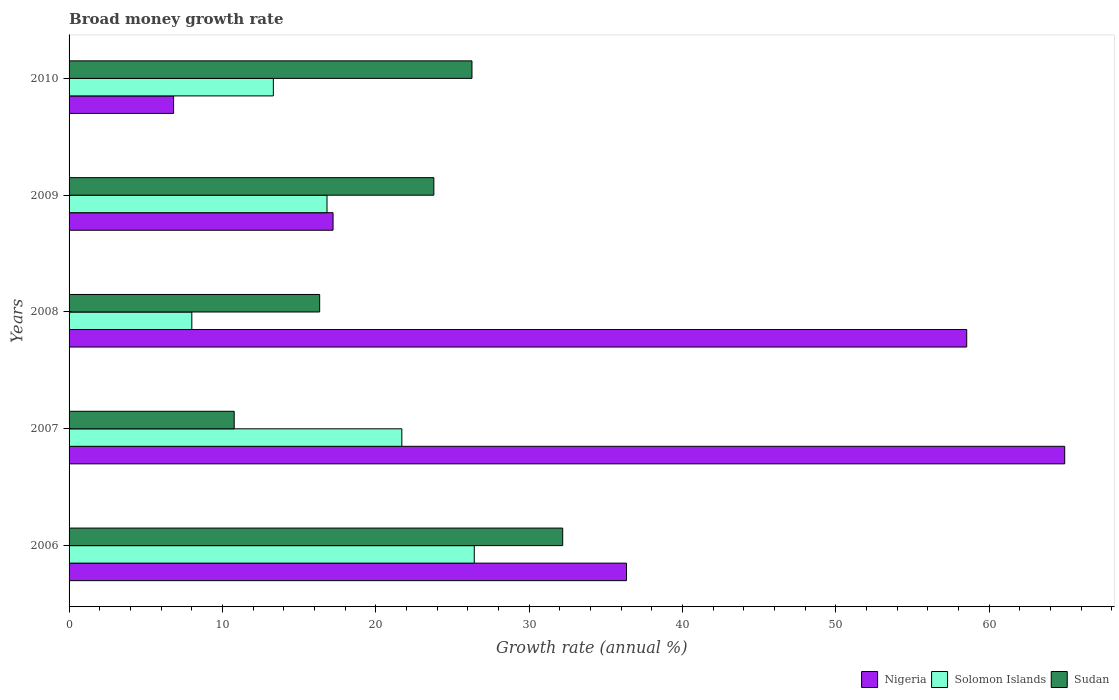How many groups of bars are there?
Give a very brief answer. 5. Are the number of bars on each tick of the Y-axis equal?
Your answer should be compact. Yes. How many bars are there on the 4th tick from the top?
Make the answer very short. 3. How many bars are there on the 1st tick from the bottom?
Offer a terse response. 3. What is the label of the 4th group of bars from the top?
Make the answer very short. 2007. In how many cases, is the number of bars for a given year not equal to the number of legend labels?
Keep it short and to the point. 0. What is the growth rate in Sudan in 2009?
Your answer should be very brief. 23.79. Across all years, what is the maximum growth rate in Nigeria?
Offer a terse response. 64.92. Across all years, what is the minimum growth rate in Nigeria?
Provide a short and direct response. 6.82. What is the total growth rate in Nigeria in the graph?
Keep it short and to the point. 183.84. What is the difference between the growth rate in Sudan in 2007 and that in 2010?
Your response must be concise. -15.5. What is the difference between the growth rate in Solomon Islands in 2010 and the growth rate in Sudan in 2007?
Ensure brevity in your answer.  2.55. What is the average growth rate in Nigeria per year?
Your response must be concise. 36.77. In the year 2008, what is the difference between the growth rate in Solomon Islands and growth rate in Nigeria?
Your response must be concise. -50.53. What is the ratio of the growth rate in Sudan in 2006 to that in 2010?
Offer a terse response. 1.23. What is the difference between the highest and the second highest growth rate in Nigeria?
Give a very brief answer. 6.39. What is the difference between the highest and the lowest growth rate in Nigeria?
Provide a short and direct response. 58.11. What does the 1st bar from the top in 2009 represents?
Provide a succinct answer. Sudan. What does the 1st bar from the bottom in 2009 represents?
Offer a terse response. Nigeria. Is it the case that in every year, the sum of the growth rate in Solomon Islands and growth rate in Nigeria is greater than the growth rate in Sudan?
Keep it short and to the point. No. How many bars are there?
Provide a succinct answer. 15. Are all the bars in the graph horizontal?
Offer a very short reply. Yes. How many years are there in the graph?
Keep it short and to the point. 5. Where does the legend appear in the graph?
Your answer should be very brief. Bottom right. How are the legend labels stacked?
Ensure brevity in your answer.  Horizontal. What is the title of the graph?
Offer a very short reply. Broad money growth rate. What is the label or title of the X-axis?
Give a very brief answer. Growth rate (annual %). What is the label or title of the Y-axis?
Provide a succinct answer. Years. What is the Growth rate (annual %) in Nigeria in 2006?
Provide a short and direct response. 36.35. What is the Growth rate (annual %) in Solomon Islands in 2006?
Give a very brief answer. 26.42. What is the Growth rate (annual %) in Sudan in 2006?
Offer a very short reply. 32.19. What is the Growth rate (annual %) of Nigeria in 2007?
Offer a terse response. 64.92. What is the Growth rate (annual %) in Solomon Islands in 2007?
Make the answer very short. 21.7. What is the Growth rate (annual %) of Sudan in 2007?
Your response must be concise. 10.77. What is the Growth rate (annual %) of Nigeria in 2008?
Make the answer very short. 58.53. What is the Growth rate (annual %) in Solomon Islands in 2008?
Your answer should be compact. 8.01. What is the Growth rate (annual %) in Sudan in 2008?
Your answer should be very brief. 16.34. What is the Growth rate (annual %) of Nigeria in 2009?
Make the answer very short. 17.21. What is the Growth rate (annual %) in Solomon Islands in 2009?
Provide a short and direct response. 16.82. What is the Growth rate (annual %) in Sudan in 2009?
Give a very brief answer. 23.79. What is the Growth rate (annual %) of Nigeria in 2010?
Provide a succinct answer. 6.82. What is the Growth rate (annual %) in Solomon Islands in 2010?
Give a very brief answer. 13.32. What is the Growth rate (annual %) of Sudan in 2010?
Make the answer very short. 26.27. Across all years, what is the maximum Growth rate (annual %) of Nigeria?
Offer a very short reply. 64.92. Across all years, what is the maximum Growth rate (annual %) of Solomon Islands?
Your answer should be compact. 26.42. Across all years, what is the maximum Growth rate (annual %) in Sudan?
Give a very brief answer. 32.19. Across all years, what is the minimum Growth rate (annual %) of Nigeria?
Keep it short and to the point. 6.82. Across all years, what is the minimum Growth rate (annual %) of Solomon Islands?
Your answer should be compact. 8.01. Across all years, what is the minimum Growth rate (annual %) in Sudan?
Offer a very short reply. 10.77. What is the total Growth rate (annual %) in Nigeria in the graph?
Ensure brevity in your answer.  183.84. What is the total Growth rate (annual %) in Solomon Islands in the graph?
Provide a succinct answer. 86.27. What is the total Growth rate (annual %) of Sudan in the graph?
Provide a succinct answer. 109.36. What is the difference between the Growth rate (annual %) in Nigeria in 2006 and that in 2007?
Ensure brevity in your answer.  -28.57. What is the difference between the Growth rate (annual %) in Solomon Islands in 2006 and that in 2007?
Provide a succinct answer. 4.72. What is the difference between the Growth rate (annual %) of Sudan in 2006 and that in 2007?
Keep it short and to the point. 21.42. What is the difference between the Growth rate (annual %) in Nigeria in 2006 and that in 2008?
Your response must be concise. -22.18. What is the difference between the Growth rate (annual %) of Solomon Islands in 2006 and that in 2008?
Offer a very short reply. 18.42. What is the difference between the Growth rate (annual %) in Sudan in 2006 and that in 2008?
Ensure brevity in your answer.  15.85. What is the difference between the Growth rate (annual %) in Nigeria in 2006 and that in 2009?
Offer a very short reply. 19.14. What is the difference between the Growth rate (annual %) of Solomon Islands in 2006 and that in 2009?
Provide a short and direct response. 9.6. What is the difference between the Growth rate (annual %) in Sudan in 2006 and that in 2009?
Keep it short and to the point. 8.4. What is the difference between the Growth rate (annual %) in Nigeria in 2006 and that in 2010?
Ensure brevity in your answer.  29.53. What is the difference between the Growth rate (annual %) in Solomon Islands in 2006 and that in 2010?
Give a very brief answer. 13.1. What is the difference between the Growth rate (annual %) of Sudan in 2006 and that in 2010?
Ensure brevity in your answer.  5.92. What is the difference between the Growth rate (annual %) in Nigeria in 2007 and that in 2008?
Give a very brief answer. 6.39. What is the difference between the Growth rate (annual %) of Solomon Islands in 2007 and that in 2008?
Ensure brevity in your answer.  13.7. What is the difference between the Growth rate (annual %) in Sudan in 2007 and that in 2008?
Ensure brevity in your answer.  -5.57. What is the difference between the Growth rate (annual %) in Nigeria in 2007 and that in 2009?
Provide a succinct answer. 47.71. What is the difference between the Growth rate (annual %) in Solomon Islands in 2007 and that in 2009?
Keep it short and to the point. 4.88. What is the difference between the Growth rate (annual %) of Sudan in 2007 and that in 2009?
Ensure brevity in your answer.  -13.02. What is the difference between the Growth rate (annual %) of Nigeria in 2007 and that in 2010?
Provide a succinct answer. 58.11. What is the difference between the Growth rate (annual %) of Solomon Islands in 2007 and that in 2010?
Ensure brevity in your answer.  8.38. What is the difference between the Growth rate (annual %) in Sudan in 2007 and that in 2010?
Provide a succinct answer. -15.5. What is the difference between the Growth rate (annual %) of Nigeria in 2008 and that in 2009?
Your answer should be compact. 41.32. What is the difference between the Growth rate (annual %) of Solomon Islands in 2008 and that in 2009?
Offer a very short reply. -8.81. What is the difference between the Growth rate (annual %) of Sudan in 2008 and that in 2009?
Your answer should be very brief. -7.45. What is the difference between the Growth rate (annual %) in Nigeria in 2008 and that in 2010?
Provide a succinct answer. 51.72. What is the difference between the Growth rate (annual %) of Solomon Islands in 2008 and that in 2010?
Make the answer very short. -5.32. What is the difference between the Growth rate (annual %) in Sudan in 2008 and that in 2010?
Keep it short and to the point. -9.93. What is the difference between the Growth rate (annual %) of Nigeria in 2009 and that in 2010?
Your answer should be very brief. 10.4. What is the difference between the Growth rate (annual %) of Solomon Islands in 2009 and that in 2010?
Ensure brevity in your answer.  3.5. What is the difference between the Growth rate (annual %) in Sudan in 2009 and that in 2010?
Offer a terse response. -2.49. What is the difference between the Growth rate (annual %) in Nigeria in 2006 and the Growth rate (annual %) in Solomon Islands in 2007?
Keep it short and to the point. 14.65. What is the difference between the Growth rate (annual %) of Nigeria in 2006 and the Growth rate (annual %) of Sudan in 2007?
Provide a succinct answer. 25.58. What is the difference between the Growth rate (annual %) of Solomon Islands in 2006 and the Growth rate (annual %) of Sudan in 2007?
Your response must be concise. 15.66. What is the difference between the Growth rate (annual %) of Nigeria in 2006 and the Growth rate (annual %) of Solomon Islands in 2008?
Your answer should be compact. 28.35. What is the difference between the Growth rate (annual %) of Nigeria in 2006 and the Growth rate (annual %) of Sudan in 2008?
Provide a short and direct response. 20.01. What is the difference between the Growth rate (annual %) in Solomon Islands in 2006 and the Growth rate (annual %) in Sudan in 2008?
Provide a short and direct response. 10.08. What is the difference between the Growth rate (annual %) in Nigeria in 2006 and the Growth rate (annual %) in Solomon Islands in 2009?
Offer a very short reply. 19.53. What is the difference between the Growth rate (annual %) of Nigeria in 2006 and the Growth rate (annual %) of Sudan in 2009?
Your response must be concise. 12.56. What is the difference between the Growth rate (annual %) of Solomon Islands in 2006 and the Growth rate (annual %) of Sudan in 2009?
Give a very brief answer. 2.64. What is the difference between the Growth rate (annual %) of Nigeria in 2006 and the Growth rate (annual %) of Solomon Islands in 2010?
Ensure brevity in your answer.  23.03. What is the difference between the Growth rate (annual %) of Nigeria in 2006 and the Growth rate (annual %) of Sudan in 2010?
Ensure brevity in your answer.  10.08. What is the difference between the Growth rate (annual %) of Solomon Islands in 2006 and the Growth rate (annual %) of Sudan in 2010?
Ensure brevity in your answer.  0.15. What is the difference between the Growth rate (annual %) of Nigeria in 2007 and the Growth rate (annual %) of Solomon Islands in 2008?
Your answer should be very brief. 56.92. What is the difference between the Growth rate (annual %) of Nigeria in 2007 and the Growth rate (annual %) of Sudan in 2008?
Your answer should be very brief. 48.58. What is the difference between the Growth rate (annual %) in Solomon Islands in 2007 and the Growth rate (annual %) in Sudan in 2008?
Your response must be concise. 5.36. What is the difference between the Growth rate (annual %) in Nigeria in 2007 and the Growth rate (annual %) in Solomon Islands in 2009?
Your response must be concise. 48.11. What is the difference between the Growth rate (annual %) of Nigeria in 2007 and the Growth rate (annual %) of Sudan in 2009?
Offer a very short reply. 41.14. What is the difference between the Growth rate (annual %) in Solomon Islands in 2007 and the Growth rate (annual %) in Sudan in 2009?
Your answer should be compact. -2.09. What is the difference between the Growth rate (annual %) of Nigeria in 2007 and the Growth rate (annual %) of Solomon Islands in 2010?
Give a very brief answer. 51.6. What is the difference between the Growth rate (annual %) in Nigeria in 2007 and the Growth rate (annual %) in Sudan in 2010?
Offer a terse response. 38.65. What is the difference between the Growth rate (annual %) in Solomon Islands in 2007 and the Growth rate (annual %) in Sudan in 2010?
Give a very brief answer. -4.57. What is the difference between the Growth rate (annual %) of Nigeria in 2008 and the Growth rate (annual %) of Solomon Islands in 2009?
Offer a very short reply. 41.71. What is the difference between the Growth rate (annual %) of Nigeria in 2008 and the Growth rate (annual %) of Sudan in 2009?
Your response must be concise. 34.75. What is the difference between the Growth rate (annual %) of Solomon Islands in 2008 and the Growth rate (annual %) of Sudan in 2009?
Your answer should be very brief. -15.78. What is the difference between the Growth rate (annual %) in Nigeria in 2008 and the Growth rate (annual %) in Solomon Islands in 2010?
Give a very brief answer. 45.21. What is the difference between the Growth rate (annual %) in Nigeria in 2008 and the Growth rate (annual %) in Sudan in 2010?
Keep it short and to the point. 32.26. What is the difference between the Growth rate (annual %) in Solomon Islands in 2008 and the Growth rate (annual %) in Sudan in 2010?
Your response must be concise. -18.27. What is the difference between the Growth rate (annual %) of Nigeria in 2009 and the Growth rate (annual %) of Solomon Islands in 2010?
Provide a short and direct response. 3.89. What is the difference between the Growth rate (annual %) of Nigeria in 2009 and the Growth rate (annual %) of Sudan in 2010?
Your response must be concise. -9.06. What is the difference between the Growth rate (annual %) of Solomon Islands in 2009 and the Growth rate (annual %) of Sudan in 2010?
Your answer should be compact. -9.45. What is the average Growth rate (annual %) of Nigeria per year?
Provide a succinct answer. 36.77. What is the average Growth rate (annual %) in Solomon Islands per year?
Provide a short and direct response. 17.25. What is the average Growth rate (annual %) of Sudan per year?
Your response must be concise. 21.87. In the year 2006, what is the difference between the Growth rate (annual %) in Nigeria and Growth rate (annual %) in Solomon Islands?
Your answer should be very brief. 9.93. In the year 2006, what is the difference between the Growth rate (annual %) in Nigeria and Growth rate (annual %) in Sudan?
Keep it short and to the point. 4.16. In the year 2006, what is the difference between the Growth rate (annual %) of Solomon Islands and Growth rate (annual %) of Sudan?
Keep it short and to the point. -5.77. In the year 2007, what is the difference between the Growth rate (annual %) of Nigeria and Growth rate (annual %) of Solomon Islands?
Give a very brief answer. 43.22. In the year 2007, what is the difference between the Growth rate (annual %) of Nigeria and Growth rate (annual %) of Sudan?
Offer a very short reply. 54.16. In the year 2007, what is the difference between the Growth rate (annual %) in Solomon Islands and Growth rate (annual %) in Sudan?
Offer a terse response. 10.93. In the year 2008, what is the difference between the Growth rate (annual %) in Nigeria and Growth rate (annual %) in Solomon Islands?
Make the answer very short. 50.53. In the year 2008, what is the difference between the Growth rate (annual %) of Nigeria and Growth rate (annual %) of Sudan?
Provide a short and direct response. 42.19. In the year 2008, what is the difference between the Growth rate (annual %) of Solomon Islands and Growth rate (annual %) of Sudan?
Ensure brevity in your answer.  -8.34. In the year 2009, what is the difference between the Growth rate (annual %) of Nigeria and Growth rate (annual %) of Solomon Islands?
Your response must be concise. 0.4. In the year 2009, what is the difference between the Growth rate (annual %) in Nigeria and Growth rate (annual %) in Sudan?
Offer a terse response. -6.57. In the year 2009, what is the difference between the Growth rate (annual %) of Solomon Islands and Growth rate (annual %) of Sudan?
Provide a short and direct response. -6.97. In the year 2010, what is the difference between the Growth rate (annual %) of Nigeria and Growth rate (annual %) of Solomon Islands?
Offer a very short reply. -6.5. In the year 2010, what is the difference between the Growth rate (annual %) of Nigeria and Growth rate (annual %) of Sudan?
Make the answer very short. -19.46. In the year 2010, what is the difference between the Growth rate (annual %) of Solomon Islands and Growth rate (annual %) of Sudan?
Give a very brief answer. -12.95. What is the ratio of the Growth rate (annual %) in Nigeria in 2006 to that in 2007?
Your response must be concise. 0.56. What is the ratio of the Growth rate (annual %) of Solomon Islands in 2006 to that in 2007?
Your answer should be compact. 1.22. What is the ratio of the Growth rate (annual %) of Sudan in 2006 to that in 2007?
Offer a terse response. 2.99. What is the ratio of the Growth rate (annual %) of Nigeria in 2006 to that in 2008?
Provide a succinct answer. 0.62. What is the ratio of the Growth rate (annual %) of Solomon Islands in 2006 to that in 2008?
Your response must be concise. 3.3. What is the ratio of the Growth rate (annual %) of Sudan in 2006 to that in 2008?
Offer a terse response. 1.97. What is the ratio of the Growth rate (annual %) in Nigeria in 2006 to that in 2009?
Offer a terse response. 2.11. What is the ratio of the Growth rate (annual %) in Solomon Islands in 2006 to that in 2009?
Your answer should be very brief. 1.57. What is the ratio of the Growth rate (annual %) of Sudan in 2006 to that in 2009?
Provide a succinct answer. 1.35. What is the ratio of the Growth rate (annual %) in Nigeria in 2006 to that in 2010?
Give a very brief answer. 5.33. What is the ratio of the Growth rate (annual %) of Solomon Islands in 2006 to that in 2010?
Make the answer very short. 1.98. What is the ratio of the Growth rate (annual %) in Sudan in 2006 to that in 2010?
Your response must be concise. 1.23. What is the ratio of the Growth rate (annual %) in Nigeria in 2007 to that in 2008?
Keep it short and to the point. 1.11. What is the ratio of the Growth rate (annual %) of Solomon Islands in 2007 to that in 2008?
Provide a short and direct response. 2.71. What is the ratio of the Growth rate (annual %) in Sudan in 2007 to that in 2008?
Keep it short and to the point. 0.66. What is the ratio of the Growth rate (annual %) of Nigeria in 2007 to that in 2009?
Provide a short and direct response. 3.77. What is the ratio of the Growth rate (annual %) of Solomon Islands in 2007 to that in 2009?
Offer a terse response. 1.29. What is the ratio of the Growth rate (annual %) of Sudan in 2007 to that in 2009?
Your answer should be compact. 0.45. What is the ratio of the Growth rate (annual %) in Nigeria in 2007 to that in 2010?
Ensure brevity in your answer.  9.52. What is the ratio of the Growth rate (annual %) in Solomon Islands in 2007 to that in 2010?
Offer a very short reply. 1.63. What is the ratio of the Growth rate (annual %) in Sudan in 2007 to that in 2010?
Provide a succinct answer. 0.41. What is the ratio of the Growth rate (annual %) of Nigeria in 2008 to that in 2009?
Your response must be concise. 3.4. What is the ratio of the Growth rate (annual %) of Solomon Islands in 2008 to that in 2009?
Keep it short and to the point. 0.48. What is the ratio of the Growth rate (annual %) in Sudan in 2008 to that in 2009?
Your response must be concise. 0.69. What is the ratio of the Growth rate (annual %) of Nigeria in 2008 to that in 2010?
Give a very brief answer. 8.59. What is the ratio of the Growth rate (annual %) in Solomon Islands in 2008 to that in 2010?
Offer a very short reply. 0.6. What is the ratio of the Growth rate (annual %) in Sudan in 2008 to that in 2010?
Give a very brief answer. 0.62. What is the ratio of the Growth rate (annual %) in Nigeria in 2009 to that in 2010?
Your answer should be compact. 2.53. What is the ratio of the Growth rate (annual %) of Solomon Islands in 2009 to that in 2010?
Your answer should be compact. 1.26. What is the ratio of the Growth rate (annual %) in Sudan in 2009 to that in 2010?
Your answer should be compact. 0.91. What is the difference between the highest and the second highest Growth rate (annual %) of Nigeria?
Your response must be concise. 6.39. What is the difference between the highest and the second highest Growth rate (annual %) of Solomon Islands?
Give a very brief answer. 4.72. What is the difference between the highest and the second highest Growth rate (annual %) of Sudan?
Provide a short and direct response. 5.92. What is the difference between the highest and the lowest Growth rate (annual %) of Nigeria?
Your answer should be compact. 58.11. What is the difference between the highest and the lowest Growth rate (annual %) of Solomon Islands?
Ensure brevity in your answer.  18.42. What is the difference between the highest and the lowest Growth rate (annual %) in Sudan?
Make the answer very short. 21.42. 